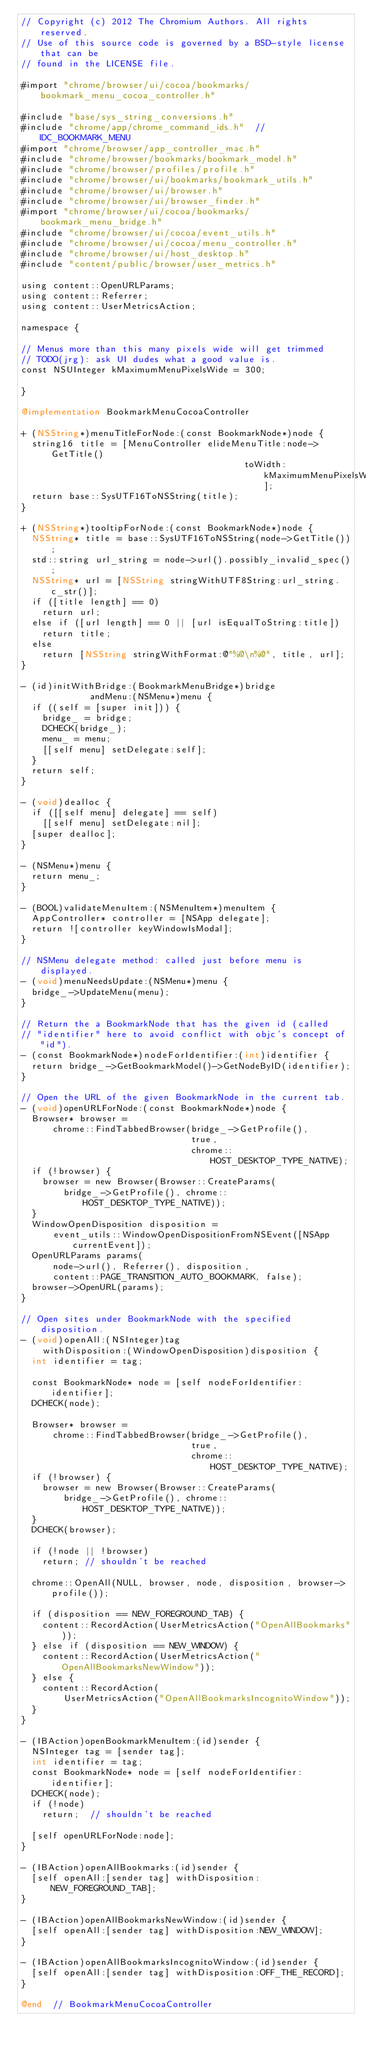<code> <loc_0><loc_0><loc_500><loc_500><_ObjectiveC_>// Copyright (c) 2012 The Chromium Authors. All rights reserved.
// Use of this source code is governed by a BSD-style license that can be
// found in the LICENSE file.

#import "chrome/browser/ui/cocoa/bookmarks/bookmark_menu_cocoa_controller.h"

#include "base/sys_string_conversions.h"
#include "chrome/app/chrome_command_ids.h"  // IDC_BOOKMARK_MENU
#import "chrome/browser/app_controller_mac.h"
#include "chrome/browser/bookmarks/bookmark_model.h"
#include "chrome/browser/profiles/profile.h"
#include "chrome/browser/ui/bookmarks/bookmark_utils.h"
#include "chrome/browser/ui/browser.h"
#include "chrome/browser/ui/browser_finder.h"
#import "chrome/browser/ui/cocoa/bookmarks/bookmark_menu_bridge.h"
#include "chrome/browser/ui/cocoa/event_utils.h"
#include "chrome/browser/ui/cocoa/menu_controller.h"
#include "chrome/browser/ui/host_desktop.h"
#include "content/public/browser/user_metrics.h"

using content::OpenURLParams;
using content::Referrer;
using content::UserMetricsAction;

namespace {

// Menus more than this many pixels wide will get trimmed
// TODO(jrg): ask UI dudes what a good value is.
const NSUInteger kMaximumMenuPixelsWide = 300;

}

@implementation BookmarkMenuCocoaController

+ (NSString*)menuTitleForNode:(const BookmarkNode*)node {
  string16 title = [MenuController elideMenuTitle:node->GetTitle()
                                          toWidth:kMaximumMenuPixelsWide];
  return base::SysUTF16ToNSString(title);
}

+ (NSString*)tooltipForNode:(const BookmarkNode*)node {
  NSString* title = base::SysUTF16ToNSString(node->GetTitle());
  std::string url_string = node->url().possibly_invalid_spec();
  NSString* url = [NSString stringWithUTF8String:url_string.c_str()];
  if ([title length] == 0)
    return url;
  else if ([url length] == 0 || [url isEqualToString:title])
    return title;
  else
    return [NSString stringWithFormat:@"%@\n%@", title, url];
}

- (id)initWithBridge:(BookmarkMenuBridge*)bridge
             andMenu:(NSMenu*)menu {
  if ((self = [super init])) {
    bridge_ = bridge;
    DCHECK(bridge_);
    menu_ = menu;
    [[self menu] setDelegate:self];
  }
  return self;
}

- (void)dealloc {
  if ([[self menu] delegate] == self)
    [[self menu] setDelegate:nil];
  [super dealloc];
}

- (NSMenu*)menu {
  return menu_;
}

- (BOOL)validateMenuItem:(NSMenuItem*)menuItem {
  AppController* controller = [NSApp delegate];
  return ![controller keyWindowIsModal];
}

// NSMenu delegate method: called just before menu is displayed.
- (void)menuNeedsUpdate:(NSMenu*)menu {
  bridge_->UpdateMenu(menu);
}

// Return the a BookmarkNode that has the given id (called
// "identifier" here to avoid conflict with objc's concept of "id").
- (const BookmarkNode*)nodeForIdentifier:(int)identifier {
  return bridge_->GetBookmarkModel()->GetNodeByID(identifier);
}

// Open the URL of the given BookmarkNode in the current tab.
- (void)openURLForNode:(const BookmarkNode*)node {
  Browser* browser =
      chrome::FindTabbedBrowser(bridge_->GetProfile(),
                                true,
                                chrome::HOST_DESKTOP_TYPE_NATIVE);
  if (!browser) {
    browser = new Browser(Browser::CreateParams(
        bridge_->GetProfile(), chrome::HOST_DESKTOP_TYPE_NATIVE));
  }
  WindowOpenDisposition disposition =
      event_utils::WindowOpenDispositionFromNSEvent([NSApp currentEvent]);
  OpenURLParams params(
      node->url(), Referrer(), disposition,
      content::PAGE_TRANSITION_AUTO_BOOKMARK, false);
  browser->OpenURL(params);
}

// Open sites under BookmarkNode with the specified disposition.
- (void)openAll:(NSInteger)tag
    withDisposition:(WindowOpenDisposition)disposition {
  int identifier = tag;

  const BookmarkNode* node = [self nodeForIdentifier:identifier];
  DCHECK(node);

  Browser* browser =
      chrome::FindTabbedBrowser(bridge_->GetProfile(),
                                true,
                                chrome::HOST_DESKTOP_TYPE_NATIVE);
  if (!browser) {
    browser = new Browser(Browser::CreateParams(
        bridge_->GetProfile(), chrome::HOST_DESKTOP_TYPE_NATIVE));
  }
  DCHECK(browser);

  if (!node || !browser)
    return; // shouldn't be reached

  chrome::OpenAll(NULL, browser, node, disposition, browser->profile());

  if (disposition == NEW_FOREGROUND_TAB) {
    content::RecordAction(UserMetricsAction("OpenAllBookmarks"));
  } else if (disposition == NEW_WINDOW) {
    content::RecordAction(UserMetricsAction("OpenAllBookmarksNewWindow"));
  } else {
    content::RecordAction(
        UserMetricsAction("OpenAllBookmarksIncognitoWindow"));
  }
}

- (IBAction)openBookmarkMenuItem:(id)sender {
  NSInteger tag = [sender tag];
  int identifier = tag;
  const BookmarkNode* node = [self nodeForIdentifier:identifier];
  DCHECK(node);
  if (!node)
    return;  // shouldn't be reached

  [self openURLForNode:node];
}

- (IBAction)openAllBookmarks:(id)sender {
  [self openAll:[sender tag] withDisposition:NEW_FOREGROUND_TAB];
}

- (IBAction)openAllBookmarksNewWindow:(id)sender {
  [self openAll:[sender tag] withDisposition:NEW_WINDOW];
}

- (IBAction)openAllBookmarksIncognitoWindow:(id)sender {
  [self openAll:[sender tag] withDisposition:OFF_THE_RECORD];
}

@end  // BookmarkMenuCocoaController
</code> 